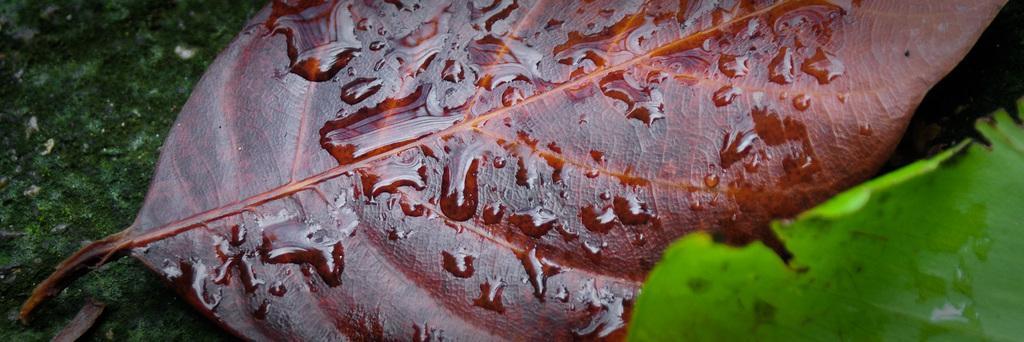Describe this image in one or two sentences. In this image I can see two leaves which are in green and brown color. To the left I can see the green color surface. 